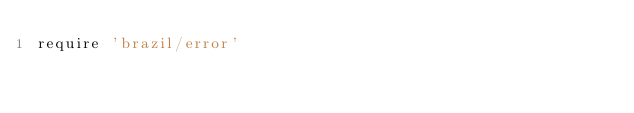<code> <loc_0><loc_0><loc_500><loc_500><_Ruby_>require 'brazil/error'
</code> 